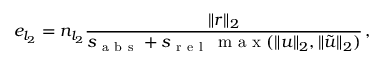<formula> <loc_0><loc_0><loc_500><loc_500>e _ { l _ { 2 } } = n _ { l _ { 2 } } \frac { \| r \| _ { 2 } } { s _ { a b s } + s _ { r e l } \, m a x ( \| u \| _ { 2 } , \| \tilde { u } \| _ { 2 } ) } \, ,</formula> 